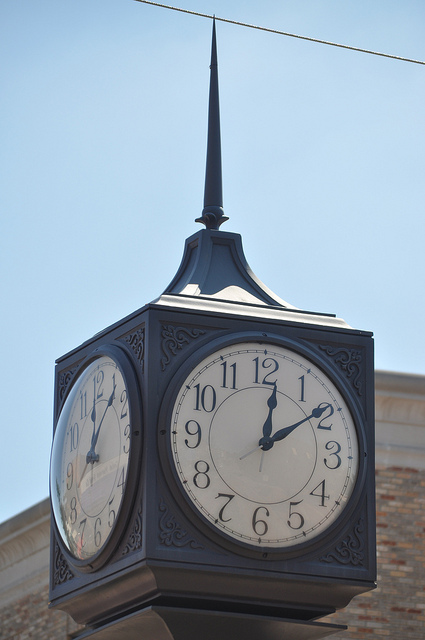Read and extract the text from this image. 12 11 1 2 3 11 10 9 8 7 6 5 4 3 2 1 12 4 5 6 2 8 9 10 